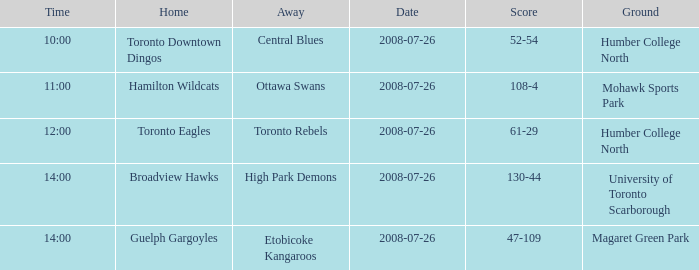When did the High Park Demons play Away? 2008-07-26. 